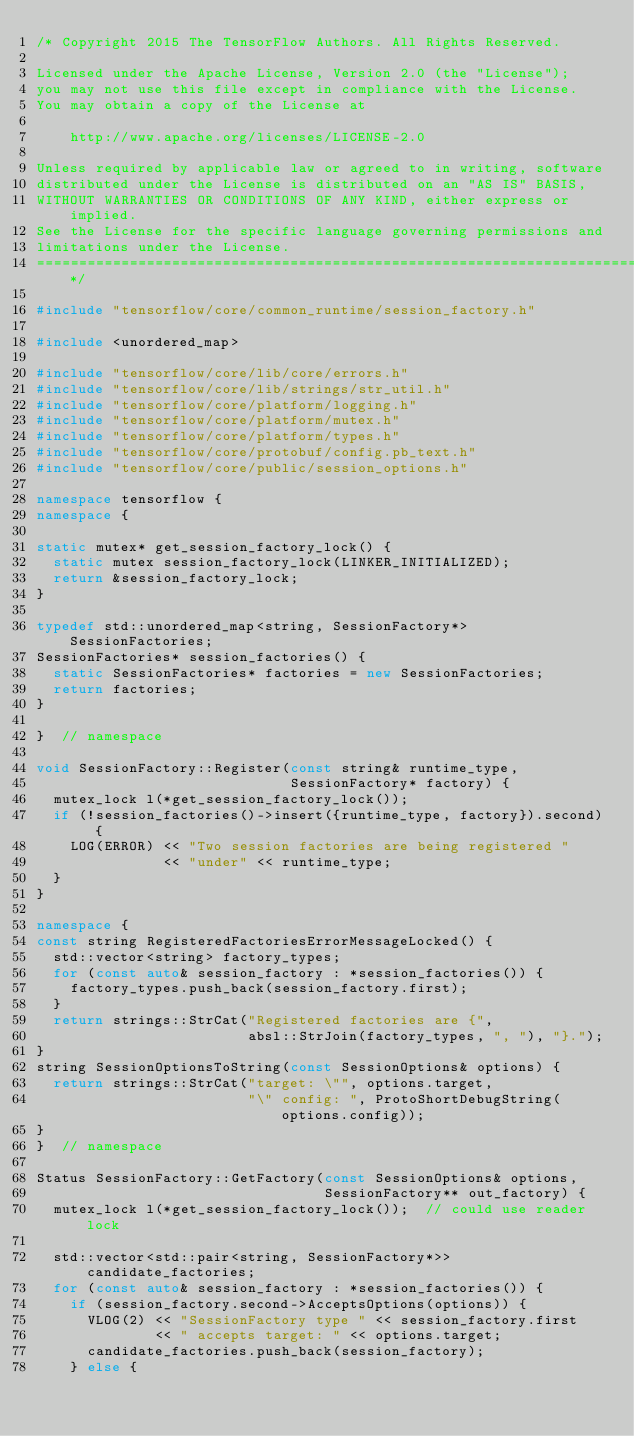Convert code to text. <code><loc_0><loc_0><loc_500><loc_500><_C++_>/* Copyright 2015 The TensorFlow Authors. All Rights Reserved.

Licensed under the Apache License, Version 2.0 (the "License");
you may not use this file except in compliance with the License.
You may obtain a copy of the License at

    http://www.apache.org/licenses/LICENSE-2.0

Unless required by applicable law or agreed to in writing, software
distributed under the License is distributed on an "AS IS" BASIS,
WITHOUT WARRANTIES OR CONDITIONS OF ANY KIND, either express or implied.
See the License for the specific language governing permissions and
limitations under the License.
==============================================================================*/

#include "tensorflow/core/common_runtime/session_factory.h"

#include <unordered_map>

#include "tensorflow/core/lib/core/errors.h"
#include "tensorflow/core/lib/strings/str_util.h"
#include "tensorflow/core/platform/logging.h"
#include "tensorflow/core/platform/mutex.h"
#include "tensorflow/core/platform/types.h"
#include "tensorflow/core/protobuf/config.pb_text.h"
#include "tensorflow/core/public/session_options.h"

namespace tensorflow {
namespace {

static mutex* get_session_factory_lock() {
  static mutex session_factory_lock(LINKER_INITIALIZED);
  return &session_factory_lock;
}

typedef std::unordered_map<string, SessionFactory*> SessionFactories;
SessionFactories* session_factories() {
  static SessionFactories* factories = new SessionFactories;
  return factories;
}

}  // namespace

void SessionFactory::Register(const string& runtime_type,
                              SessionFactory* factory) {
  mutex_lock l(*get_session_factory_lock());
  if (!session_factories()->insert({runtime_type, factory}).second) {
    LOG(ERROR) << "Two session factories are being registered "
               << "under" << runtime_type;
  }
}

namespace {
const string RegisteredFactoriesErrorMessageLocked() {
  std::vector<string> factory_types;
  for (const auto& session_factory : *session_factories()) {
    factory_types.push_back(session_factory.first);
  }
  return strings::StrCat("Registered factories are {",
                         absl::StrJoin(factory_types, ", "), "}.");
}
string SessionOptionsToString(const SessionOptions& options) {
  return strings::StrCat("target: \"", options.target,
                         "\" config: ", ProtoShortDebugString(options.config));
}
}  // namespace

Status SessionFactory::GetFactory(const SessionOptions& options,
                                  SessionFactory** out_factory) {
  mutex_lock l(*get_session_factory_lock());  // could use reader lock

  std::vector<std::pair<string, SessionFactory*>> candidate_factories;
  for (const auto& session_factory : *session_factories()) {
    if (session_factory.second->AcceptsOptions(options)) {
      VLOG(2) << "SessionFactory type " << session_factory.first
              << " accepts target: " << options.target;
      candidate_factories.push_back(session_factory);
    } else {</code> 